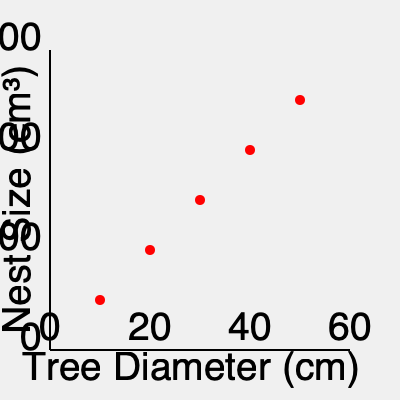Based on the scatter plot showing the relationship between tree diameter and squirrel nest size, what is the approximate increase in nest size (in cm³) for every 10 cm increase in tree diameter? To determine the approximate increase in nest size for every 10 cm increase in tree diameter, we can follow these steps:

1. Identify the overall trend: The scatter plot shows a positive linear relationship between tree diameter and nest size.

2. Calculate the total change in nest size:
   - At 0 cm tree diameter, nest size is approximately 0 cm³
   - At 60 cm tree diameter, nest size is approximately 3000 cm³
   - Total change in nest size = 3000 cm³ - 0 cm³ = 3000 cm³

3. Calculate the total change in tree diameter:
   - Range of tree diameter: 60 cm - 0 cm = 60 cm

4. Calculate the rate of change:
   Rate of change = Total change in nest size / Total change in tree diameter
   $$ \text{Rate of change} = \frac{3000 \text{ cm}³}{60 \text{ cm}} = 50 \text{ cm}³/\text{cm} $$

5. Calculate the increase in nest size for a 10 cm increase in tree diameter:
   $$ \text{Increase in nest size} = 50 \text{ cm}³/\text{cm} \times 10 \text{ cm} = 500 \text{ cm}³ $$

Therefore, the approximate increase in nest size for every 10 cm increase in tree diameter is 500 cm³.
Answer: 500 cm³ 